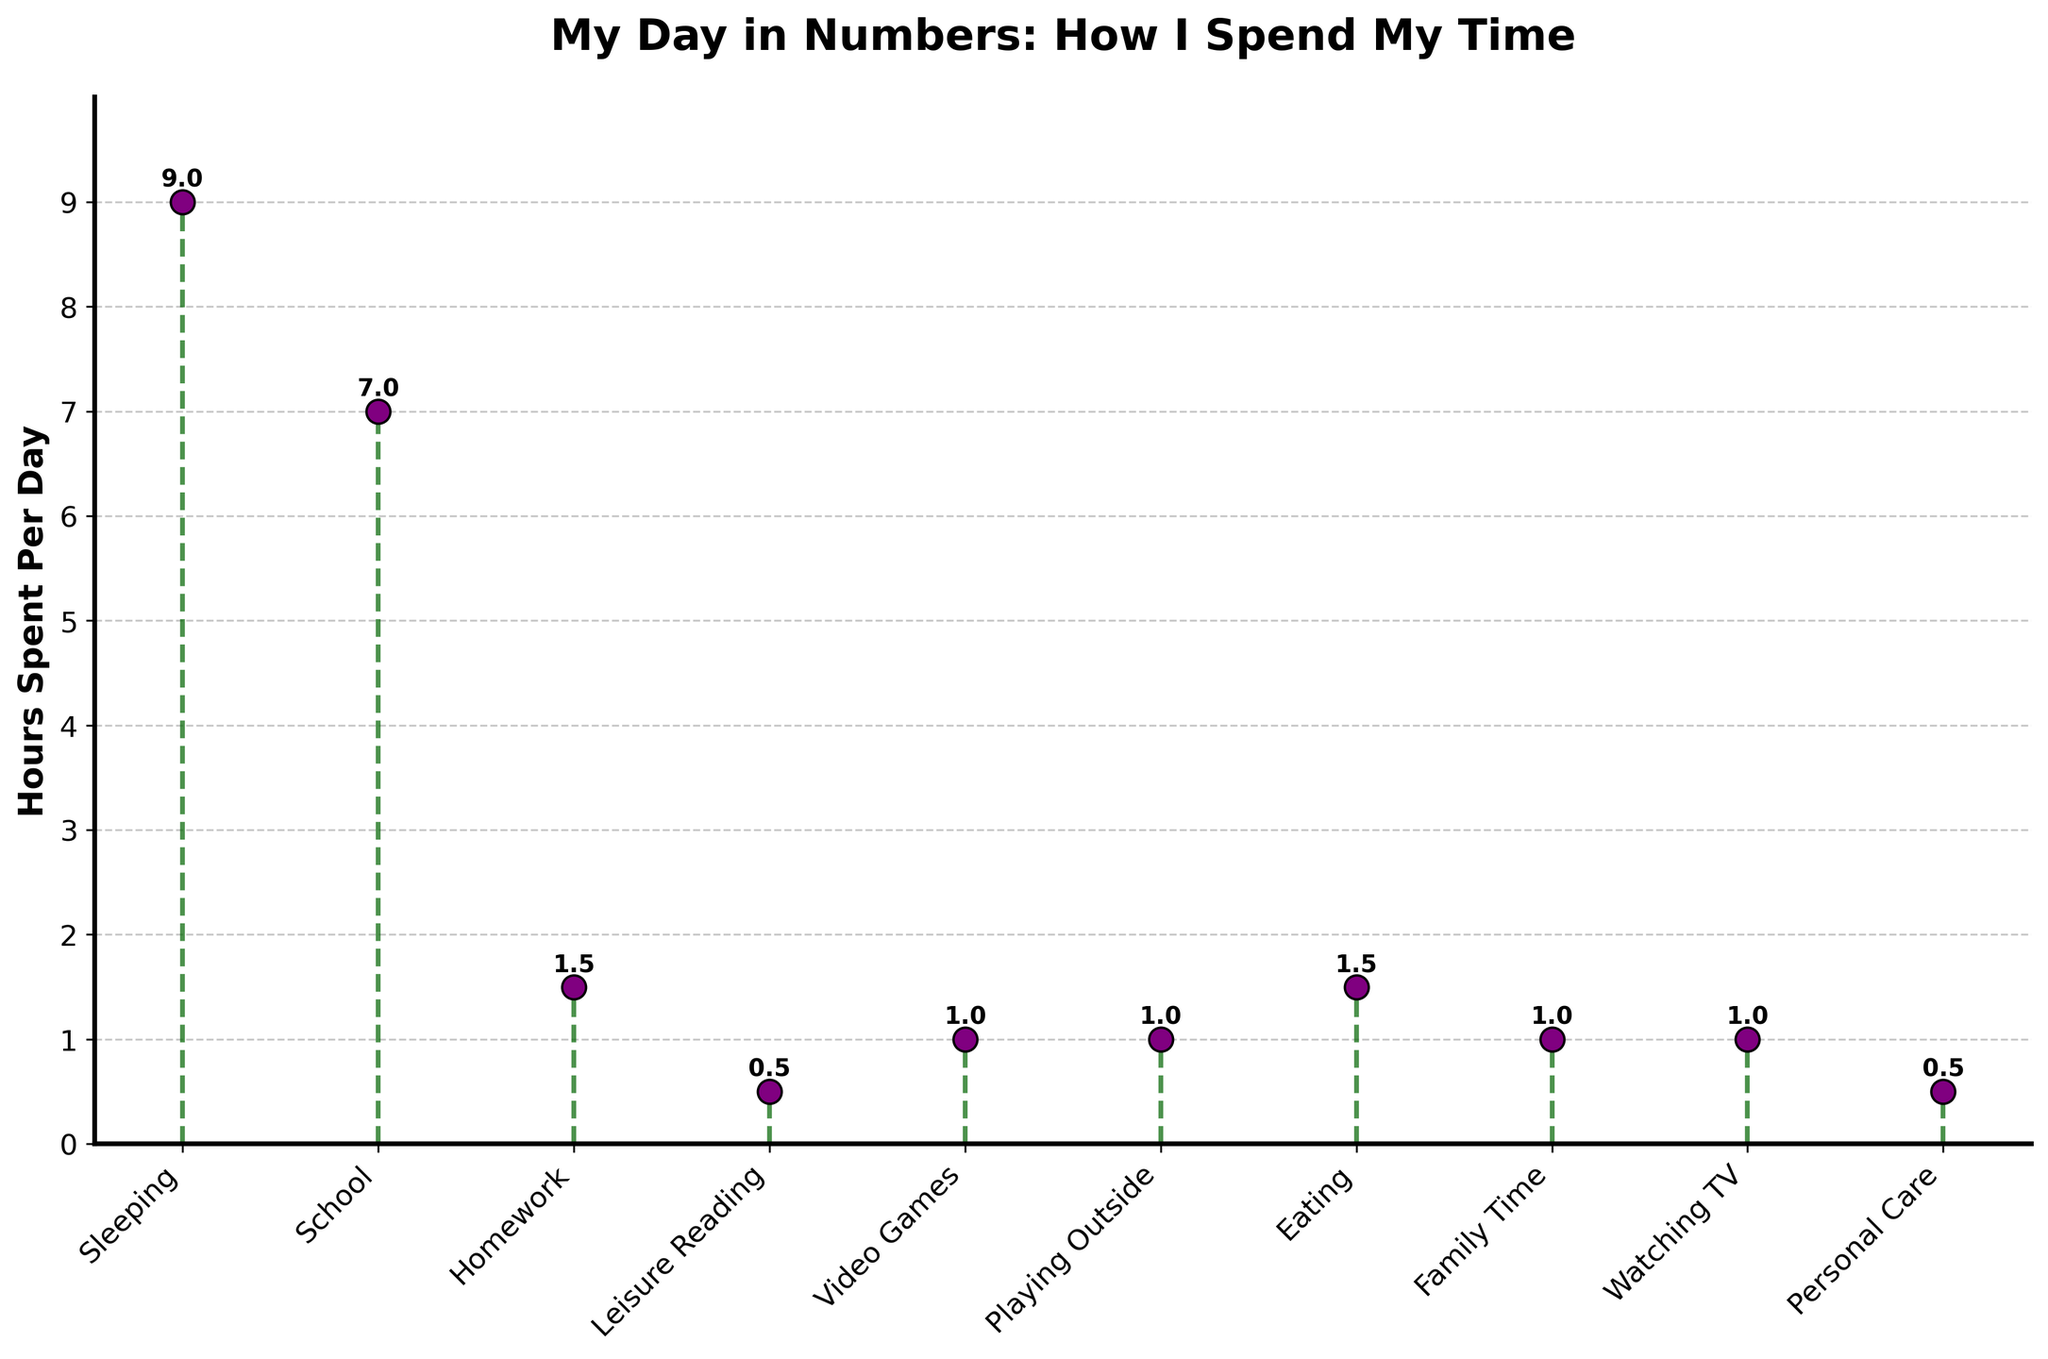What is the title of the figure? The title is usually located at the top of the figure. In this case, it reads "My Day in Numbers: How I Spend My Time".
Answer: "My Day in Numbers: How I Spend My Time" What is the total number of activities shown in the figure? You can count each activity listed along the x-axis. There are 10 activities in total.
Answer: 10 Which activity has the highest number of hours spent per day? By looking at the stem plot, you can identify the tallest marker, which represents 'Sleeping' with 9 hours.
Answer: Sleeping What is the second most time-consuming activity? After identifying the highest bar, look for the next highest, which is 'School' with 7 hours.
Answer: School How many hours does the child spend on leisure reading and video games combined? Add the hours spent on leisure reading (0.5) and video games (1). 0.5 + 1 = 1.5 hours.
Answer: 1.5 hours Is the time spent on homework greater or less than the time spent playing outside? Compare the hours for homework (1.5) and playing outside (1). Homework is greater.
Answer: Greater Which activity takes up equal time as video games and watching TV combined? First, add the hours spent on video games (1) and watching TV (1), which equals 2 hours. Then, find the activity with 2 hours, but none exists. Therefore, no activity matches this.
Answer: None How many hours in total does the child spend on activities other than sleeping and school? Add the hours spent on other activities: 1.5 (homework) + 0.5 (leisure reading) + 1 (video games) + 1 (playing outside) + 1.5 (eating) + 1 (family time) + 1 (watching TV) + 0.5 (personal care) = 8 hours.
Answer: 8 hours Are there any activities that have the same number of hours spent per day? If so, which ones? By examining the plot, you can see that video games, playing outside, watching TV, and family time each have 1 hour. Additionally, leisure reading and personal care each have 0.5 hours.
Answer: Yes, video games, playing outside, watching TV, family time (1 hour each); leisure reading, personal care (0.5 hour each) Which activity has the least number of hours spent per day? The shortest marker on the stem plot represents 'Leisure Reading' and 'Personal Care', each with 0.5 hours.
Answer: Leisure Reading and Personal Care 